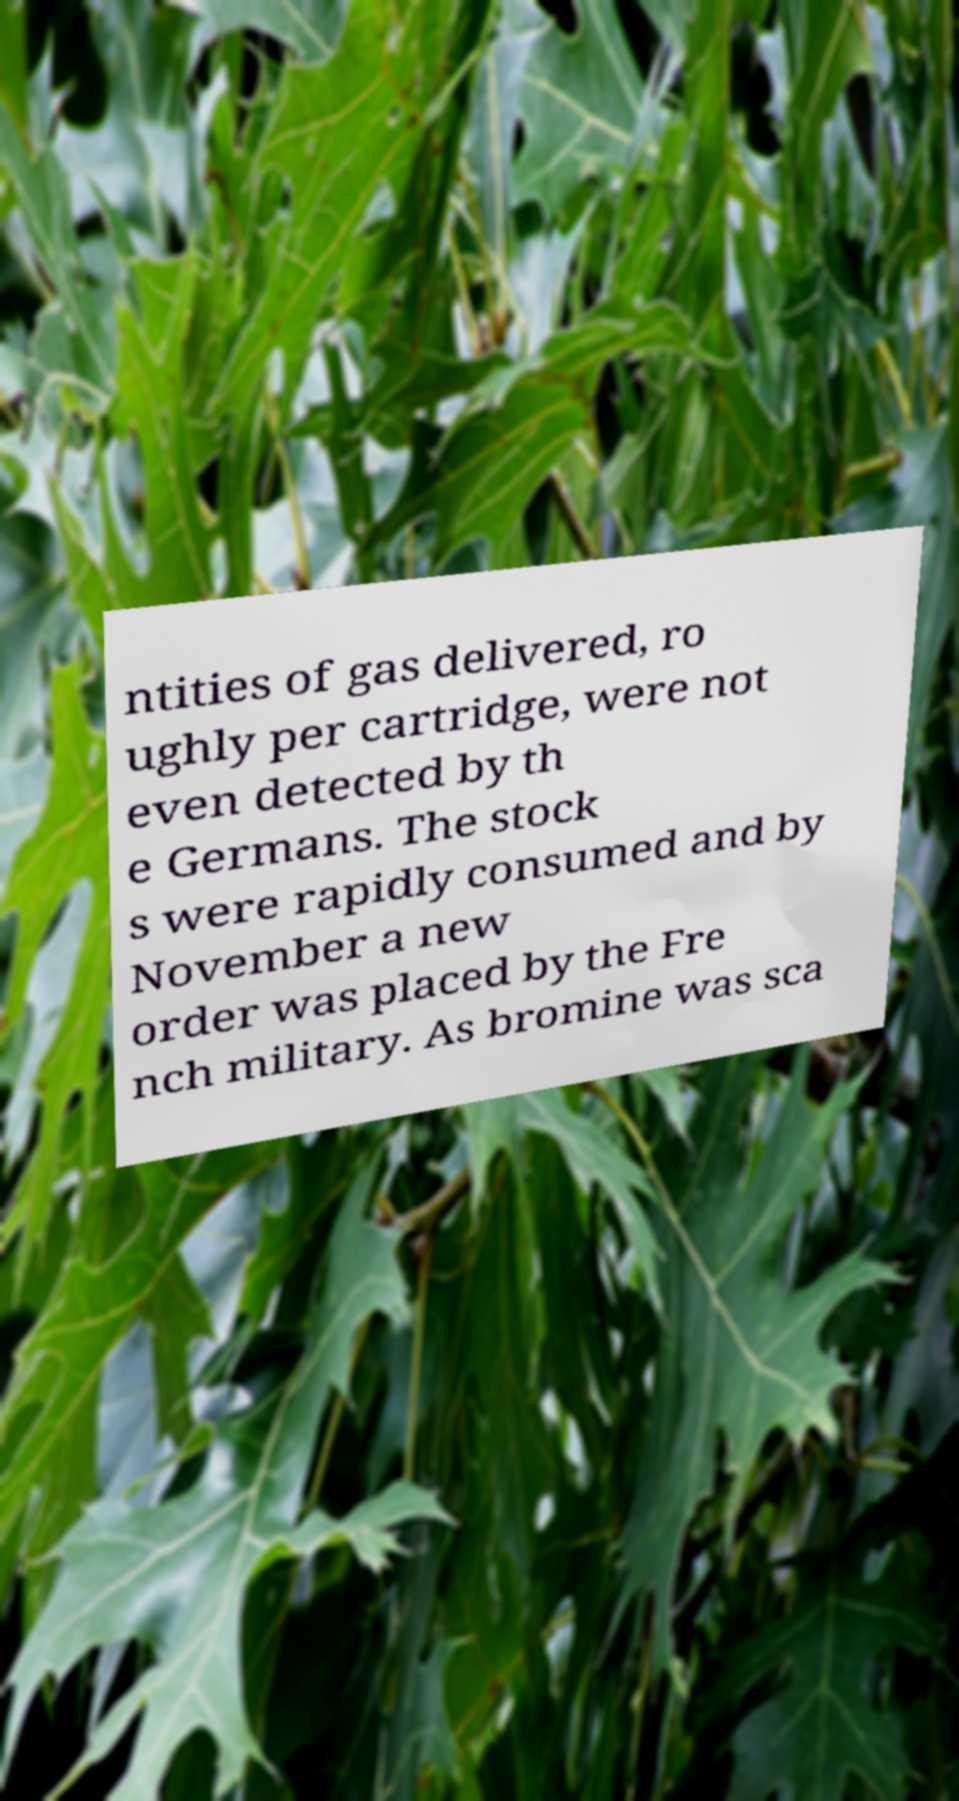For documentation purposes, I need the text within this image transcribed. Could you provide that? ntities of gas delivered, ro ughly per cartridge, were not even detected by th e Germans. The stock s were rapidly consumed and by November a new order was placed by the Fre nch military. As bromine was sca 